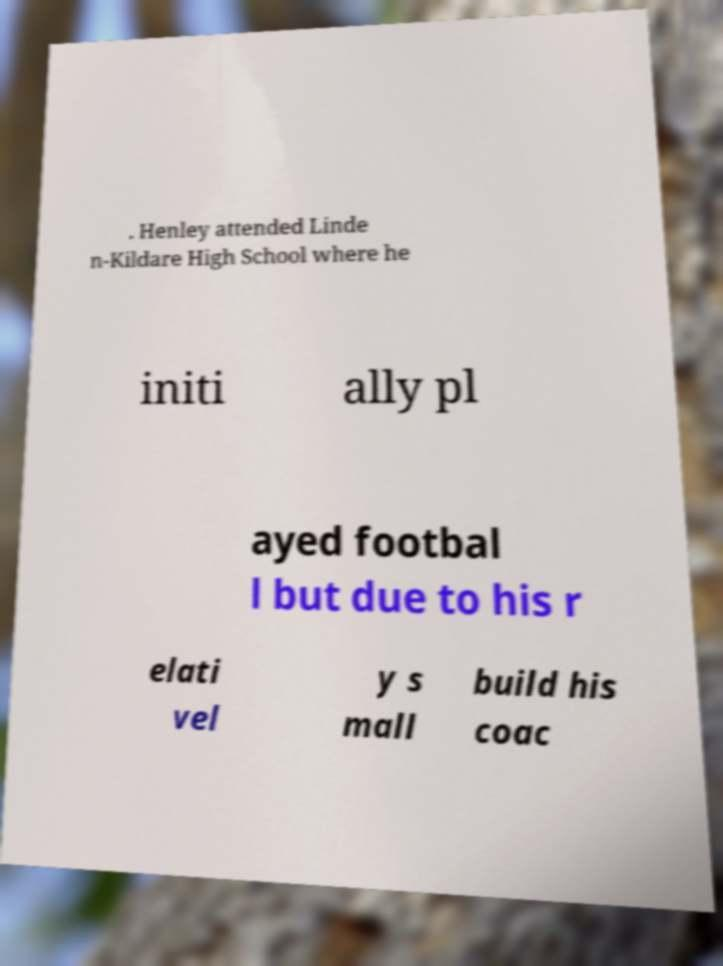Can you accurately transcribe the text from the provided image for me? . Henley attended Linde n-Kildare High School where he initi ally pl ayed footbal l but due to his r elati vel y s mall build his coac 